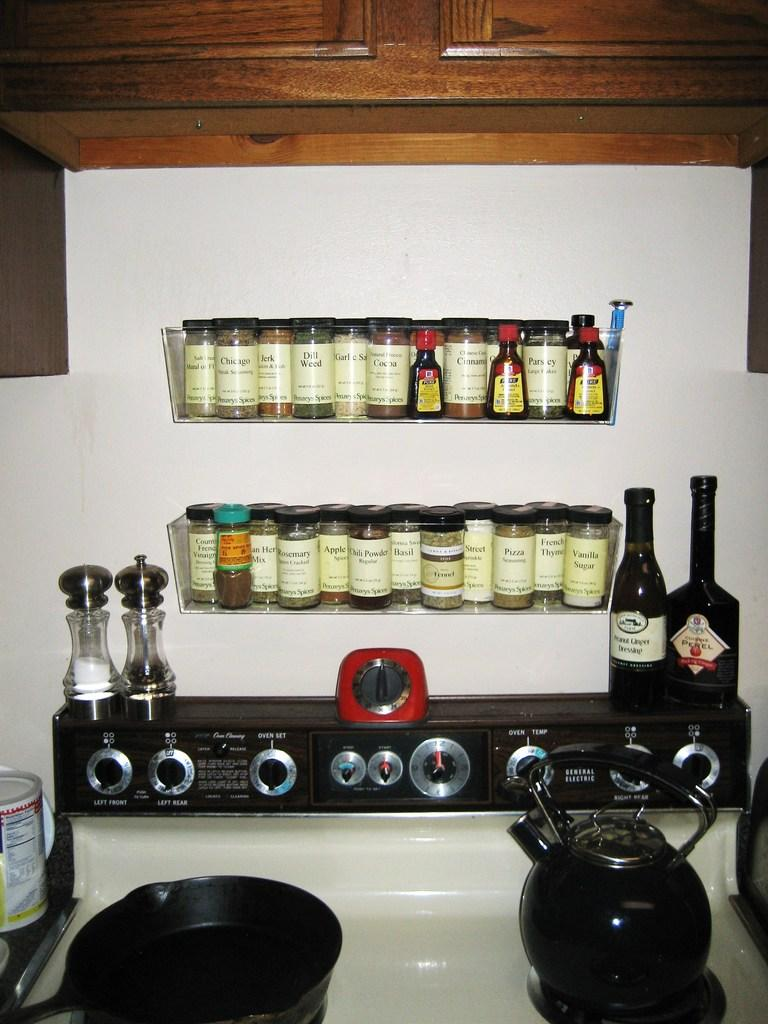<image>
Summarize the visual content of the image. A rack of spices - dill weed an garlic salt amongst them 